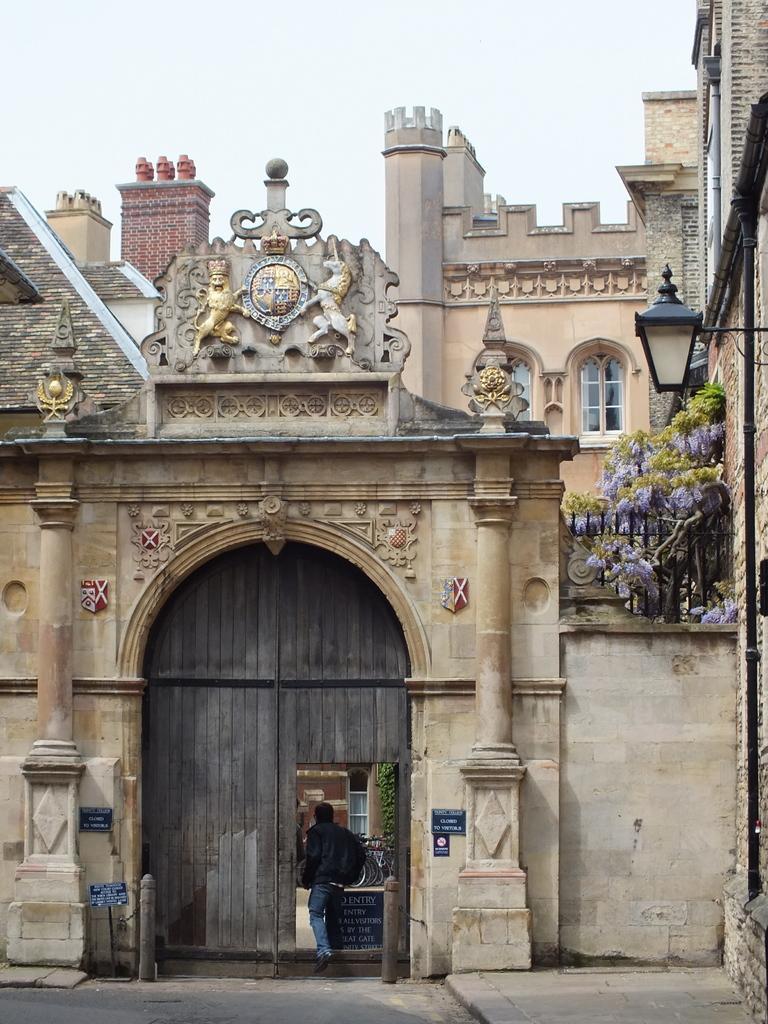In one or two sentences, can you explain what this image depicts? In this picture we can see the building, one person is wearing a bag and entering into the building. 